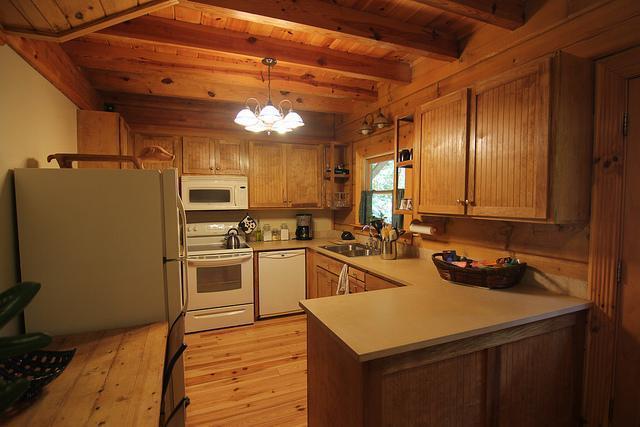How many dining tables are in the photo?
Give a very brief answer. 1. How many ovens are there?
Give a very brief answer. 1. 